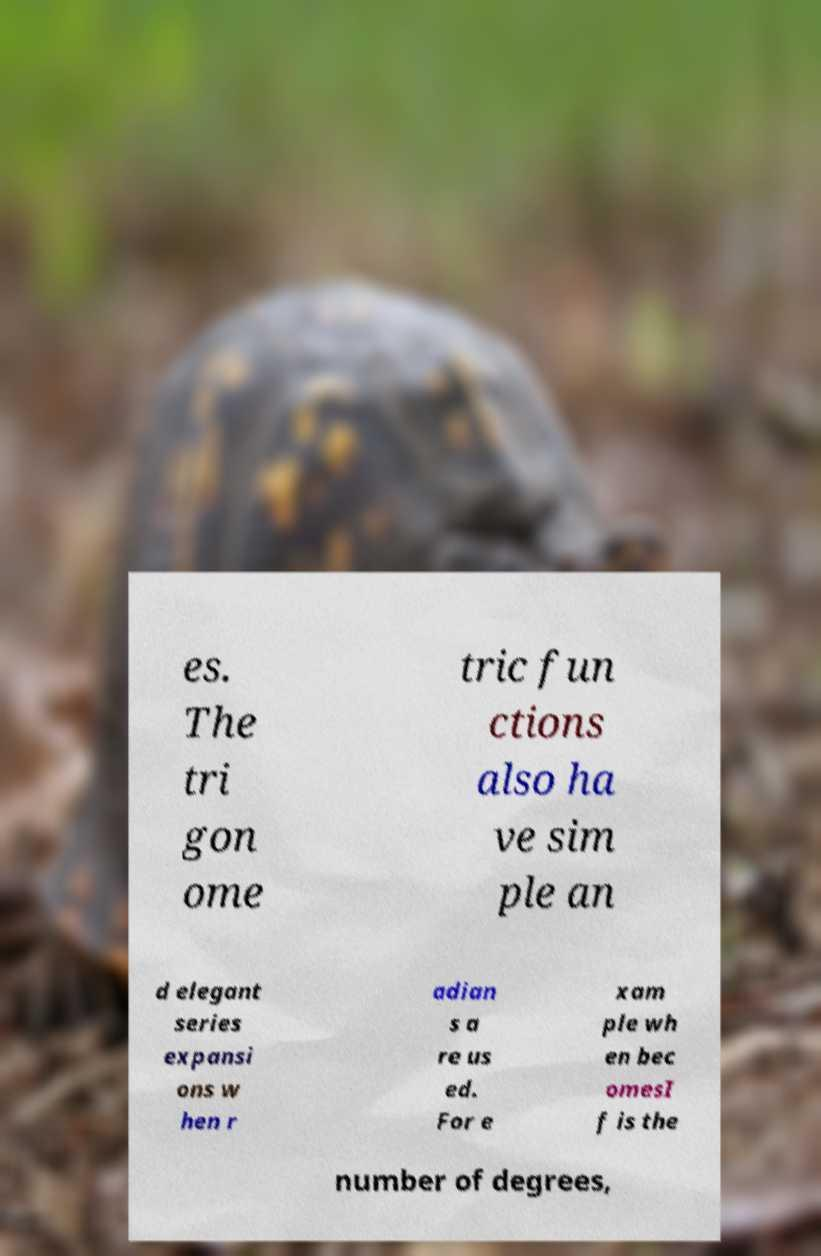Please read and relay the text visible in this image. What does it say? es. The tri gon ome tric fun ctions also ha ve sim ple an d elegant series expansi ons w hen r adian s a re us ed. For e xam ple wh en bec omesI f is the number of degrees, 